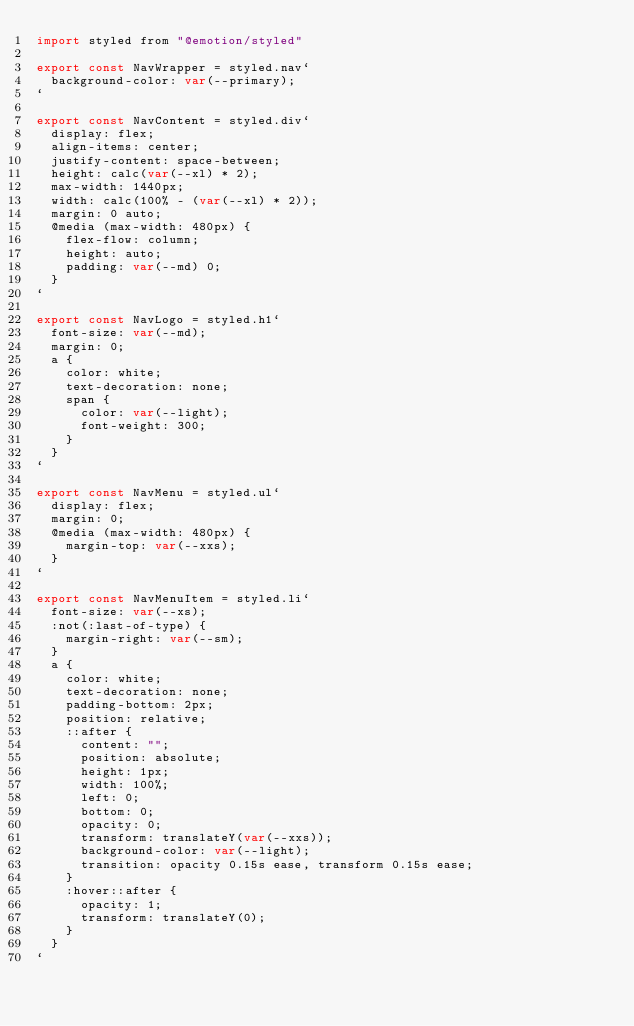Convert code to text. <code><loc_0><loc_0><loc_500><loc_500><_JavaScript_>import styled from "@emotion/styled"

export const NavWrapper = styled.nav`
  background-color: var(--primary);
`

export const NavContent = styled.div`
  display: flex;
  align-items: center;
  justify-content: space-between;
  height: calc(var(--xl) * 2);
  max-width: 1440px;
  width: calc(100% - (var(--xl) * 2));
  margin: 0 auto;
  @media (max-width: 480px) {
    flex-flow: column;
    height: auto;
    padding: var(--md) 0;
  }
`

export const NavLogo = styled.h1`
  font-size: var(--md);
  margin: 0;
  a {
    color: white;
    text-decoration: none;
    span {
      color: var(--light);
      font-weight: 300;
    }
  }
`

export const NavMenu = styled.ul`
  display: flex;
  margin: 0;
  @media (max-width: 480px) {
    margin-top: var(--xxs);
  }
`

export const NavMenuItem = styled.li`
  font-size: var(--xs);
  :not(:last-of-type) {
    margin-right: var(--sm);
  }
  a {
    color: white;
    text-decoration: none;
    padding-bottom: 2px;
    position: relative;
    ::after {
      content: "";
      position: absolute;
      height: 1px;
      width: 100%;
      left: 0;
      bottom: 0;
      opacity: 0;
      transform: translateY(var(--xxs));
      background-color: var(--light);
      transition: opacity 0.15s ease, transform 0.15s ease;
    }
    :hover::after {
      opacity: 1;
      transform: translateY(0);
    }
  }
`
</code> 